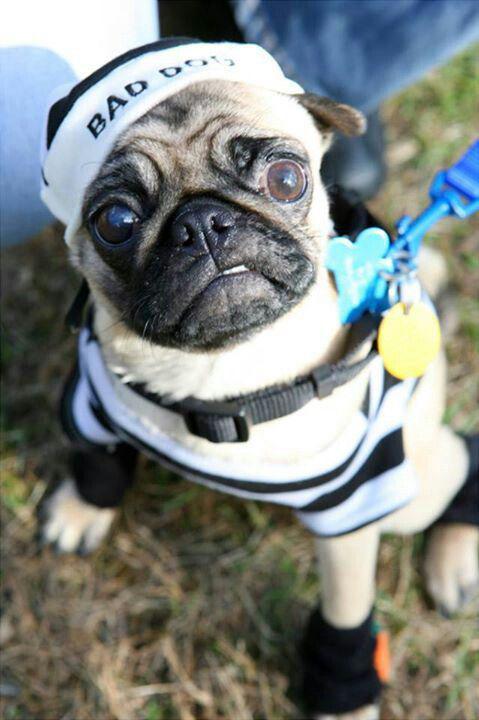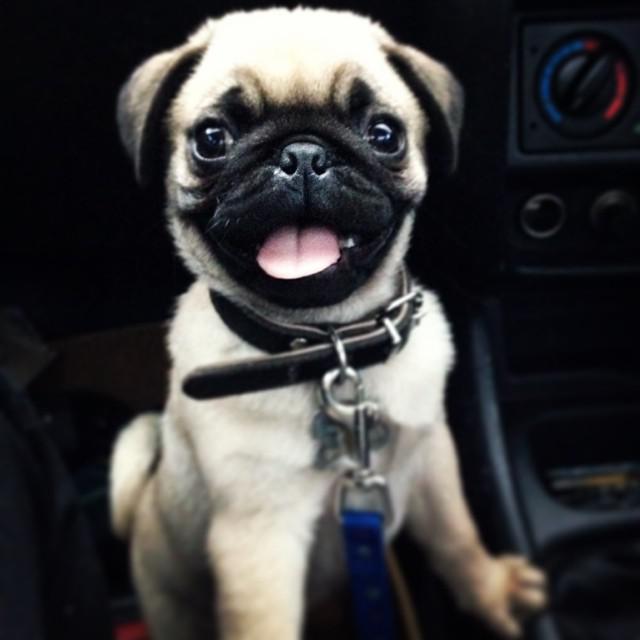The first image is the image on the left, the second image is the image on the right. Evaluate the accuracy of this statement regarding the images: "One image shows a camera-facing sitting pug with something bright blue hanging downward from its neck.". Is it true? Answer yes or no. Yes. The first image is the image on the left, the second image is the image on the right. Assess this claim about the two images: "Only the dog in the image on the left is wearing a collar.". Correct or not? Answer yes or no. No. 